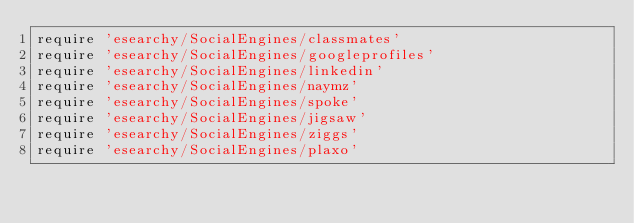<code> <loc_0><loc_0><loc_500><loc_500><_Ruby_>require 'esearchy/SocialEngines/classmates'
require 'esearchy/SocialEngines/googleprofiles'
require 'esearchy/SocialEngines/linkedin'
require 'esearchy/SocialEngines/naymz'
require 'esearchy/SocialEngines/spoke'
require 'esearchy/SocialEngines/jigsaw'
require 'esearchy/SocialEngines/ziggs'
require 'esearchy/SocialEngines/plaxo'</code> 